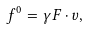<formula> <loc_0><loc_0><loc_500><loc_500>f ^ { 0 } = \gamma F \cdot v ,</formula> 